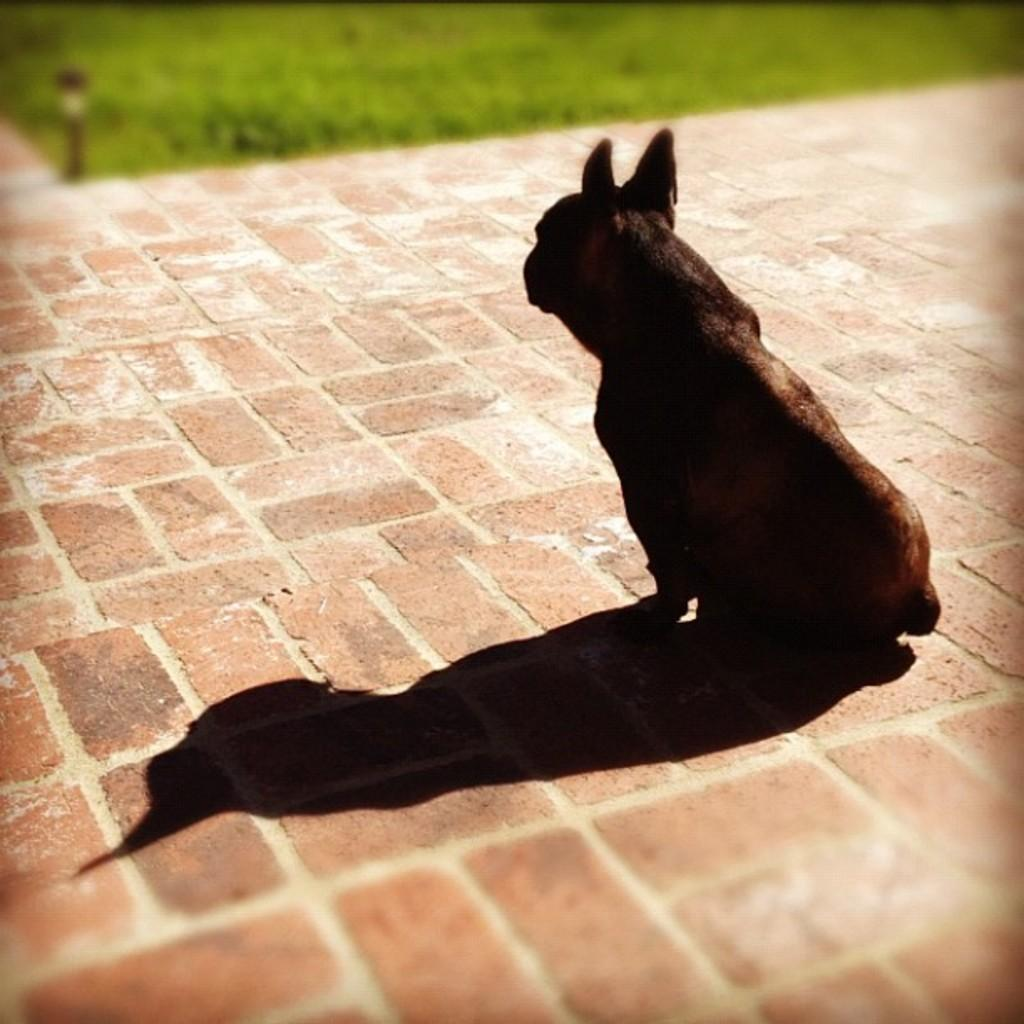What type of animal can be seen in the picture? There is an animal in the picture, but its specific type cannot be determined from the provided facts. Where is the animal located in the image? The animal is sitting on a path in the image. Can you describe the path in the image? The path has a brick design. What type of vegetation is visible in the image? There is grass visible in the image. What brand of soda is being advertised on the committee in the image? There is no mention of a committee or soda in the image; it features an animal sitting on a brick path with grass visible. 